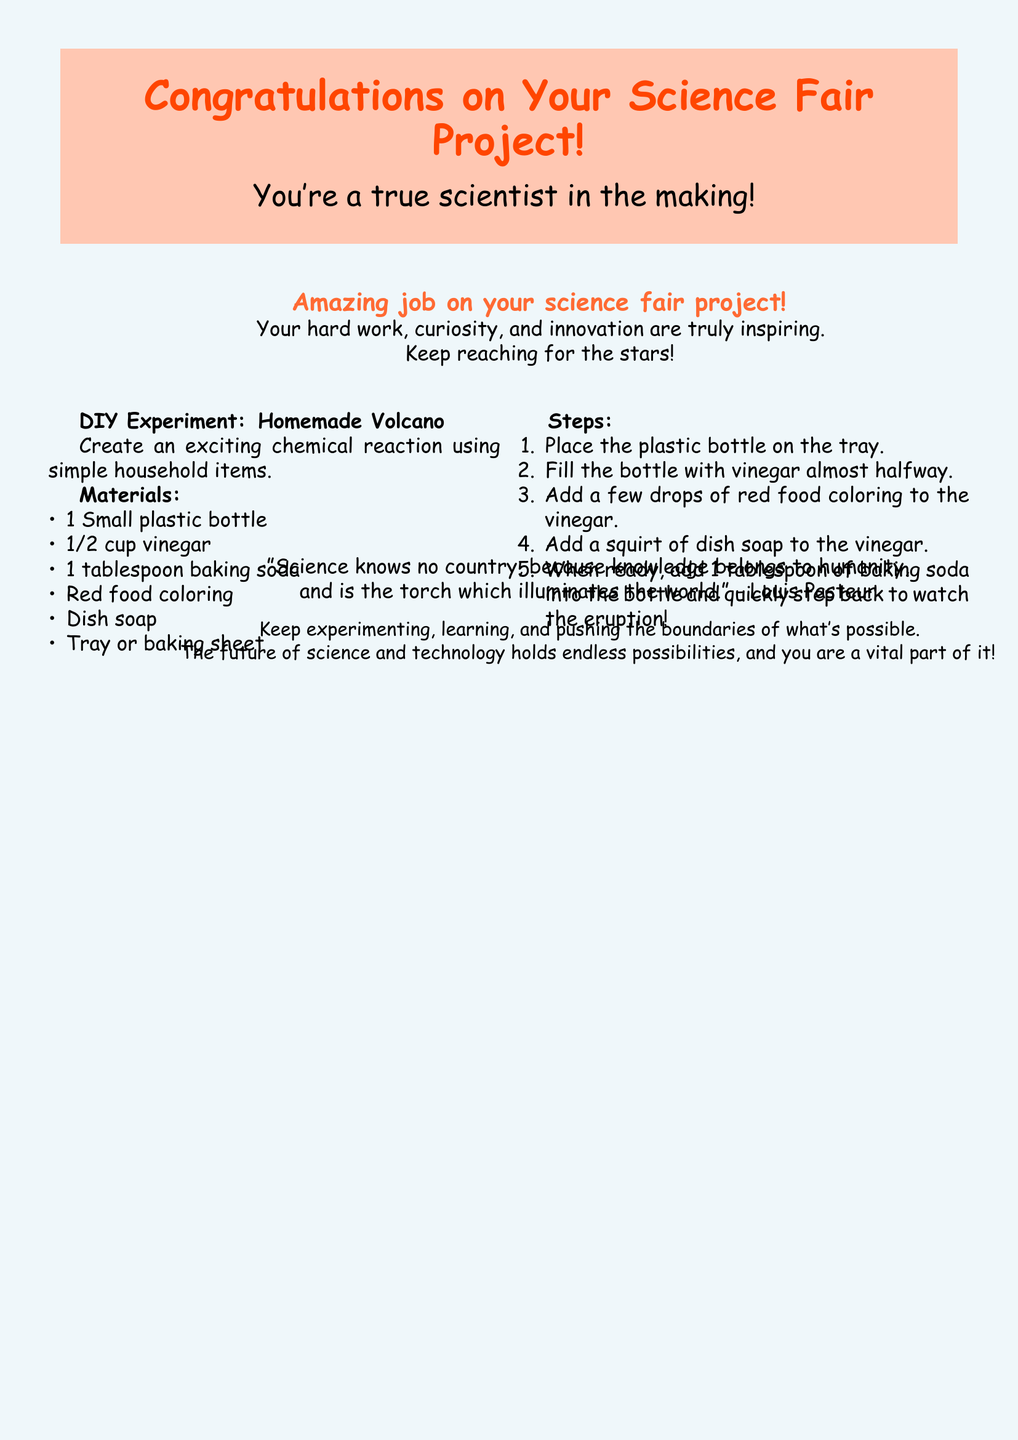What is the title of the card? The title is prominently displayed at the top of the card, celebrating the achievement.
Answer: Congratulations on Your Science Fair Project! Who is depicted on the cover? The cover shows a child who is presumably representing a budding scientist.
Answer: A child What colors are used in the design? The document features the colors rocket red and lab coat blue prominently throughout its design.
Answer: Rocket red and lab coat blue What is the first line inside the card? The first line inside the card offers a compliment regarding the recipient's potential as a scientist.
Answer: You're a true scientist in the making! What household item is used for the DIY experiment? The experiment requires common household items to create the volcano effect.
Answer: Vinegar How many steps are there in the DIY experiment? The number of steps to complete the experiment makes it easy to follow and engaging.
Answer: Five steps What quote is included in the document? A thoughtful quote is provided which relates to the value of science and knowledge.
Answer: "Science knows no country, because knowledge belongs to humanity..." What type of experiment is suggested in the card? The card suggests a science experiment that is engaging and visually exciting for the recipient.
Answer: Homemade Volcano What do the colors in the card likely represent? The colors chosen convey a playful and inviting tone appropriate for celebrating a science accomplishment.
Answer: Playful and inviting tone 